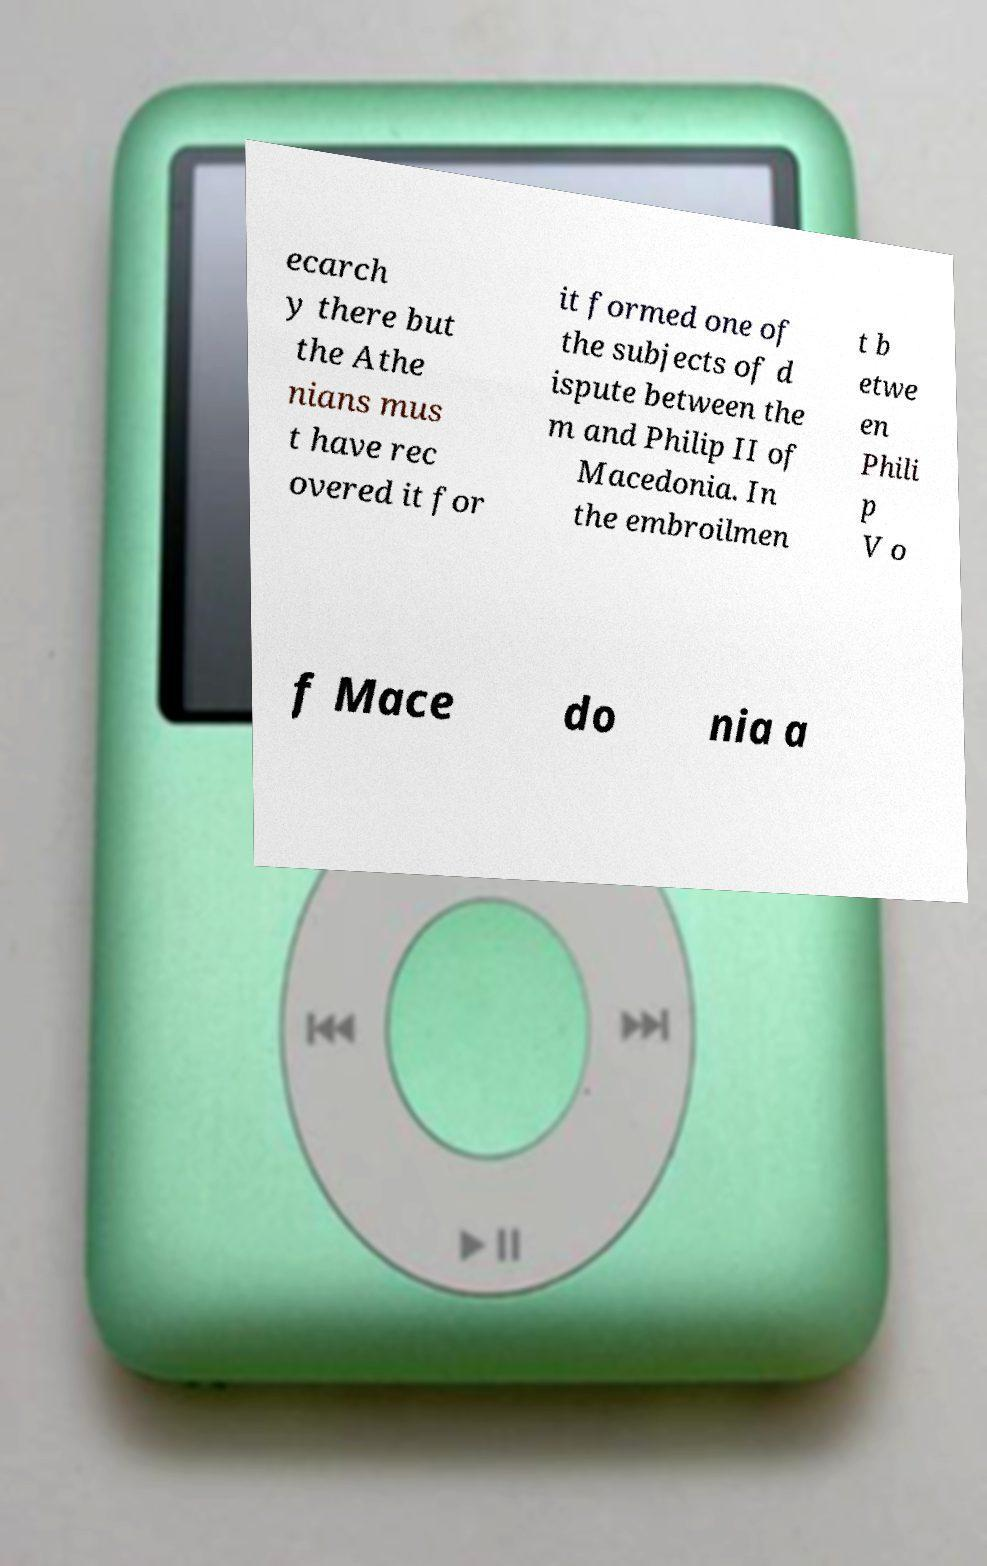Please identify and transcribe the text found in this image. ecarch y there but the Athe nians mus t have rec overed it for it formed one of the subjects of d ispute between the m and Philip II of Macedonia. In the embroilmen t b etwe en Phili p V o f Mace do nia a 